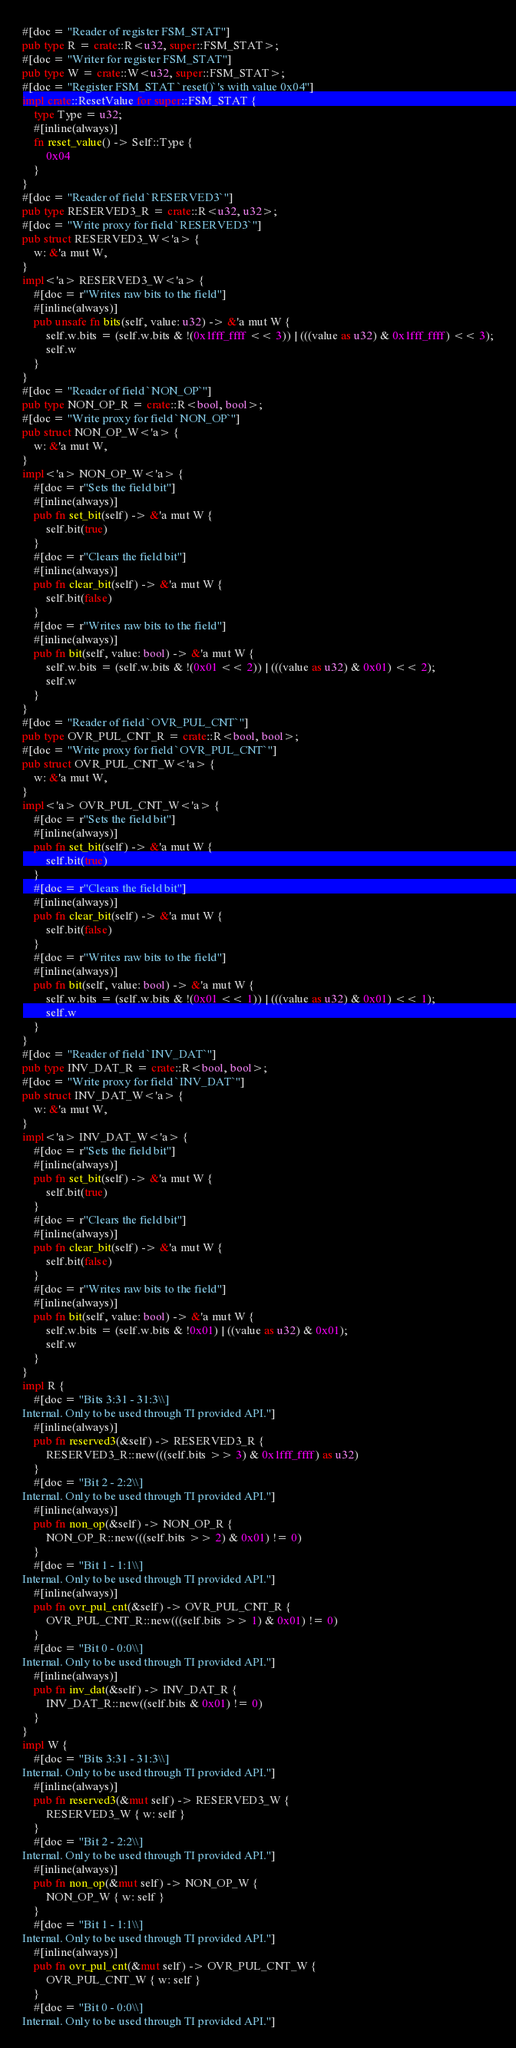Convert code to text. <code><loc_0><loc_0><loc_500><loc_500><_Rust_>#[doc = "Reader of register FSM_STAT"]
pub type R = crate::R<u32, super::FSM_STAT>;
#[doc = "Writer for register FSM_STAT"]
pub type W = crate::W<u32, super::FSM_STAT>;
#[doc = "Register FSM_STAT `reset()`'s with value 0x04"]
impl crate::ResetValue for super::FSM_STAT {
    type Type = u32;
    #[inline(always)]
    fn reset_value() -> Self::Type {
        0x04
    }
}
#[doc = "Reader of field `RESERVED3`"]
pub type RESERVED3_R = crate::R<u32, u32>;
#[doc = "Write proxy for field `RESERVED3`"]
pub struct RESERVED3_W<'a> {
    w: &'a mut W,
}
impl<'a> RESERVED3_W<'a> {
    #[doc = r"Writes raw bits to the field"]
    #[inline(always)]
    pub unsafe fn bits(self, value: u32) -> &'a mut W {
        self.w.bits = (self.w.bits & !(0x1fff_ffff << 3)) | (((value as u32) & 0x1fff_ffff) << 3);
        self.w
    }
}
#[doc = "Reader of field `NON_OP`"]
pub type NON_OP_R = crate::R<bool, bool>;
#[doc = "Write proxy for field `NON_OP`"]
pub struct NON_OP_W<'a> {
    w: &'a mut W,
}
impl<'a> NON_OP_W<'a> {
    #[doc = r"Sets the field bit"]
    #[inline(always)]
    pub fn set_bit(self) -> &'a mut W {
        self.bit(true)
    }
    #[doc = r"Clears the field bit"]
    #[inline(always)]
    pub fn clear_bit(self) -> &'a mut W {
        self.bit(false)
    }
    #[doc = r"Writes raw bits to the field"]
    #[inline(always)]
    pub fn bit(self, value: bool) -> &'a mut W {
        self.w.bits = (self.w.bits & !(0x01 << 2)) | (((value as u32) & 0x01) << 2);
        self.w
    }
}
#[doc = "Reader of field `OVR_PUL_CNT`"]
pub type OVR_PUL_CNT_R = crate::R<bool, bool>;
#[doc = "Write proxy for field `OVR_PUL_CNT`"]
pub struct OVR_PUL_CNT_W<'a> {
    w: &'a mut W,
}
impl<'a> OVR_PUL_CNT_W<'a> {
    #[doc = r"Sets the field bit"]
    #[inline(always)]
    pub fn set_bit(self) -> &'a mut W {
        self.bit(true)
    }
    #[doc = r"Clears the field bit"]
    #[inline(always)]
    pub fn clear_bit(self) -> &'a mut W {
        self.bit(false)
    }
    #[doc = r"Writes raw bits to the field"]
    #[inline(always)]
    pub fn bit(self, value: bool) -> &'a mut W {
        self.w.bits = (self.w.bits & !(0x01 << 1)) | (((value as u32) & 0x01) << 1);
        self.w
    }
}
#[doc = "Reader of field `INV_DAT`"]
pub type INV_DAT_R = crate::R<bool, bool>;
#[doc = "Write proxy for field `INV_DAT`"]
pub struct INV_DAT_W<'a> {
    w: &'a mut W,
}
impl<'a> INV_DAT_W<'a> {
    #[doc = r"Sets the field bit"]
    #[inline(always)]
    pub fn set_bit(self) -> &'a mut W {
        self.bit(true)
    }
    #[doc = r"Clears the field bit"]
    #[inline(always)]
    pub fn clear_bit(self) -> &'a mut W {
        self.bit(false)
    }
    #[doc = r"Writes raw bits to the field"]
    #[inline(always)]
    pub fn bit(self, value: bool) -> &'a mut W {
        self.w.bits = (self.w.bits & !0x01) | ((value as u32) & 0x01);
        self.w
    }
}
impl R {
    #[doc = "Bits 3:31 - 31:3\\]
Internal. Only to be used through TI provided API."]
    #[inline(always)]
    pub fn reserved3(&self) -> RESERVED3_R {
        RESERVED3_R::new(((self.bits >> 3) & 0x1fff_ffff) as u32)
    }
    #[doc = "Bit 2 - 2:2\\]
Internal. Only to be used through TI provided API."]
    #[inline(always)]
    pub fn non_op(&self) -> NON_OP_R {
        NON_OP_R::new(((self.bits >> 2) & 0x01) != 0)
    }
    #[doc = "Bit 1 - 1:1\\]
Internal. Only to be used through TI provided API."]
    #[inline(always)]
    pub fn ovr_pul_cnt(&self) -> OVR_PUL_CNT_R {
        OVR_PUL_CNT_R::new(((self.bits >> 1) & 0x01) != 0)
    }
    #[doc = "Bit 0 - 0:0\\]
Internal. Only to be used through TI provided API."]
    #[inline(always)]
    pub fn inv_dat(&self) -> INV_DAT_R {
        INV_DAT_R::new((self.bits & 0x01) != 0)
    }
}
impl W {
    #[doc = "Bits 3:31 - 31:3\\]
Internal. Only to be used through TI provided API."]
    #[inline(always)]
    pub fn reserved3(&mut self) -> RESERVED3_W {
        RESERVED3_W { w: self }
    }
    #[doc = "Bit 2 - 2:2\\]
Internal. Only to be used through TI provided API."]
    #[inline(always)]
    pub fn non_op(&mut self) -> NON_OP_W {
        NON_OP_W { w: self }
    }
    #[doc = "Bit 1 - 1:1\\]
Internal. Only to be used through TI provided API."]
    #[inline(always)]
    pub fn ovr_pul_cnt(&mut self) -> OVR_PUL_CNT_W {
        OVR_PUL_CNT_W { w: self }
    }
    #[doc = "Bit 0 - 0:0\\]
Internal. Only to be used through TI provided API."]</code> 